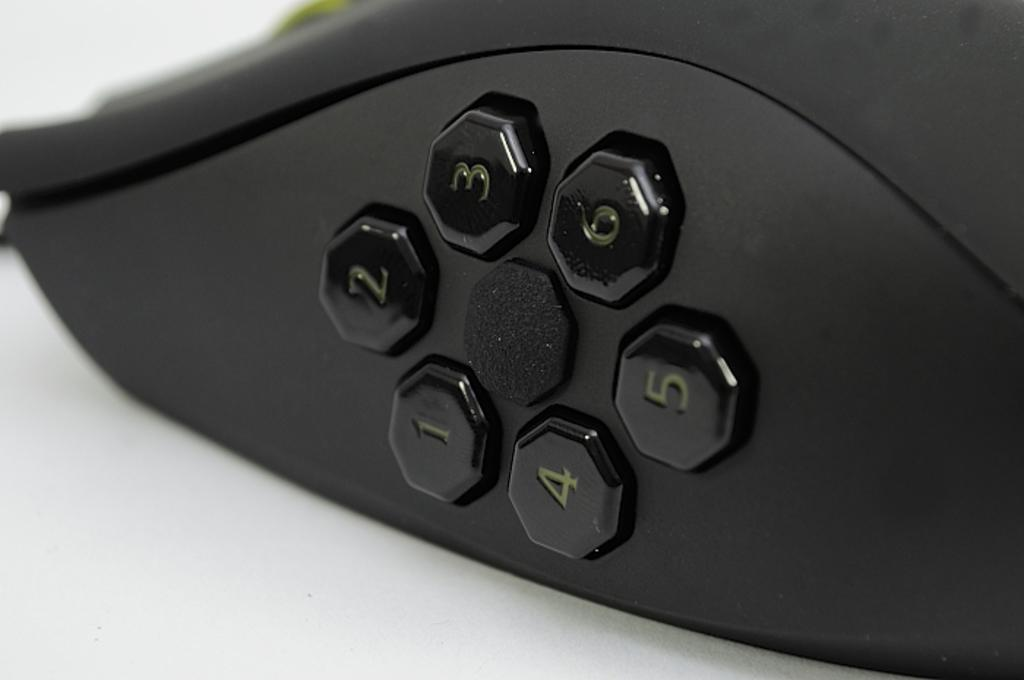What is the main object in the image? There is a device in the image. Where is the device located? The device is on the ground. What type of business is being conducted in the image? There is no indication of any business being conducted in the image, as it only features a device on the ground. 